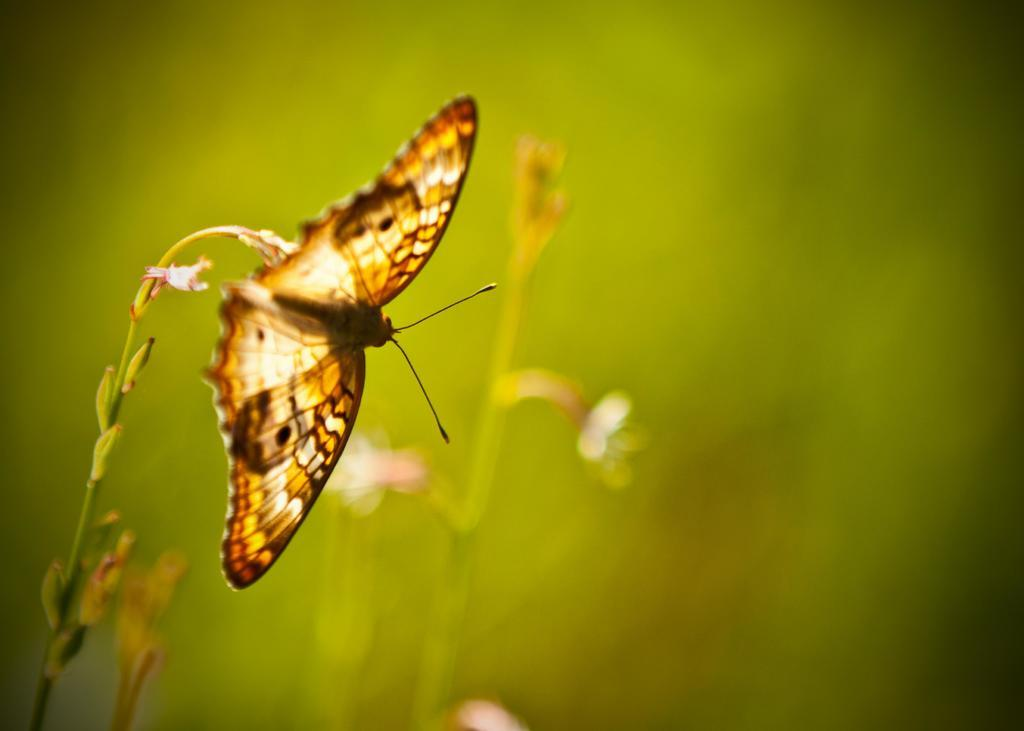What type of creature can be seen in the image? There is a butterfly in the image. What other living organisms are present in the image? There are plants and flowers in the image. What color is predominant in the background of the image? The background of the image is green. What type of afterthought can be seen in the image? There is no afterthought present in the image; it features a butterfly, plants, and flowers. Can you tell me how many thumbs are visible in the image? There are no thumbs visible in the image. 